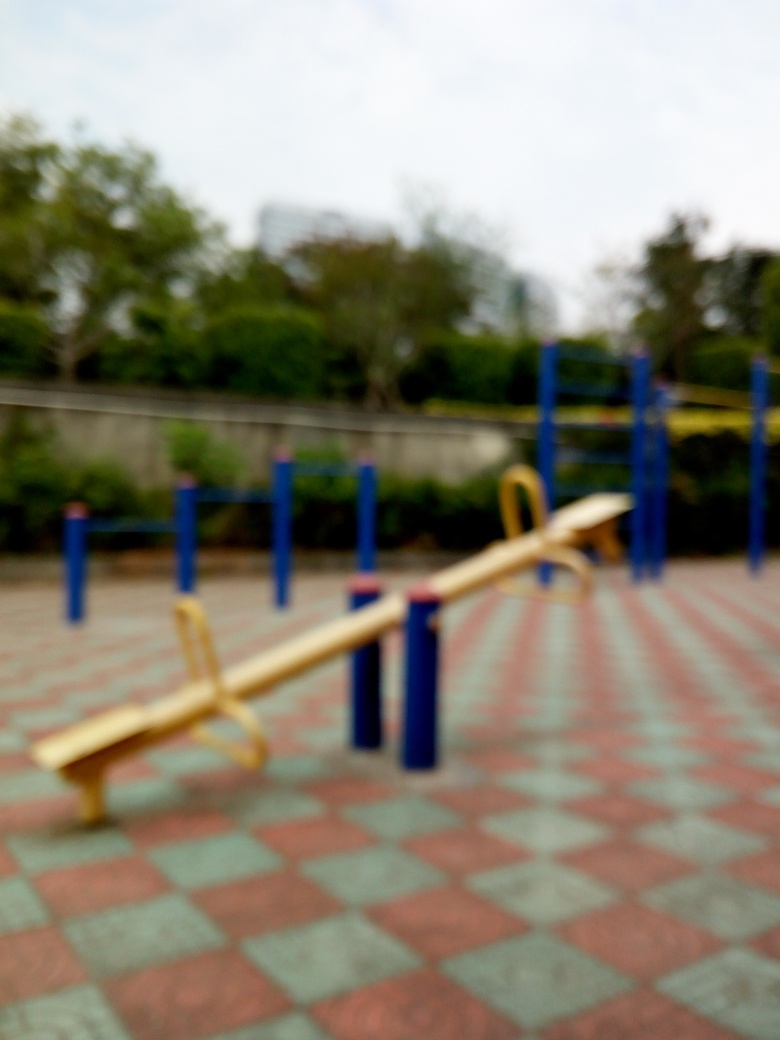Is the playground safe for children to play in based on this image? From the image, the playground appears to be designed with safety in mind. The seesaw is installed over a patterned, paved area that seems to be flat and even, reducing tripping hazards. However, there is no visible protective surfacing like rubber mulch or mats that can cushion falls, which is a recommended safety feature for playgrounds. Additionally, since the image is not entirely clear, a physical inspection would be necessary to ensure full safety compliance. 